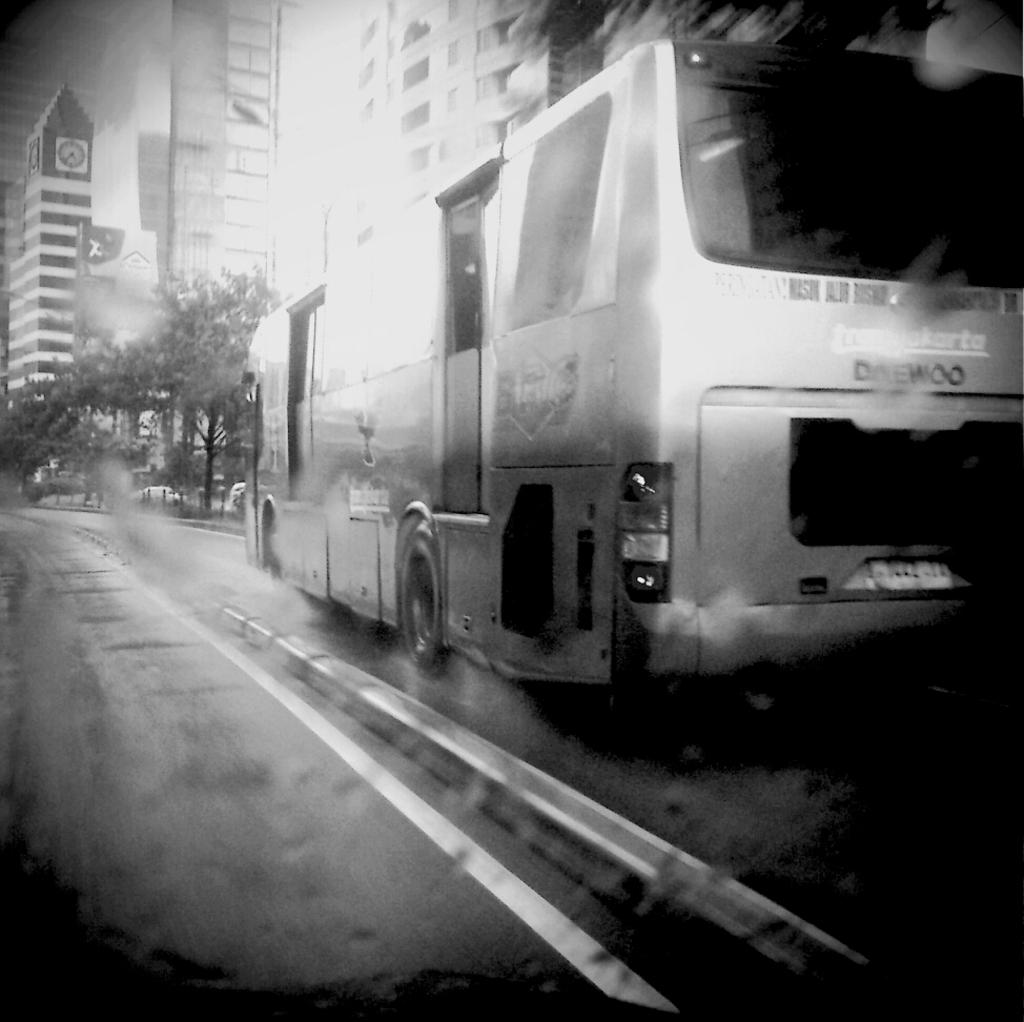What is the color scheme of the image? The image is black and white. What can be seen on the road in the image? There is a bus on the road in the image. What type of vegetation is visible in the image? There are trees visible in the image. What type of structures can be seen in the image? There are buildings in the image. What type of breakfast is being served at the protest in the image? There is no protest or breakfast present in the image; it features a black and white scene with a bus on the road, trees, and buildings. Can you tell me how many chickens are visible in the image? There are no chickens present in the image. 